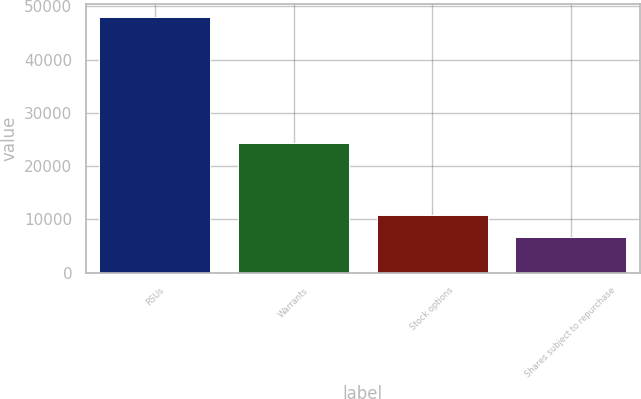Convert chart to OTSL. <chart><loc_0><loc_0><loc_500><loc_500><bar_chart><fcel>RSUs<fcel>Warrants<fcel>Stock options<fcel>Shares subject to repurchase<nl><fcel>48069<fcel>24329<fcel>10780.2<fcel>6637<nl></chart> 